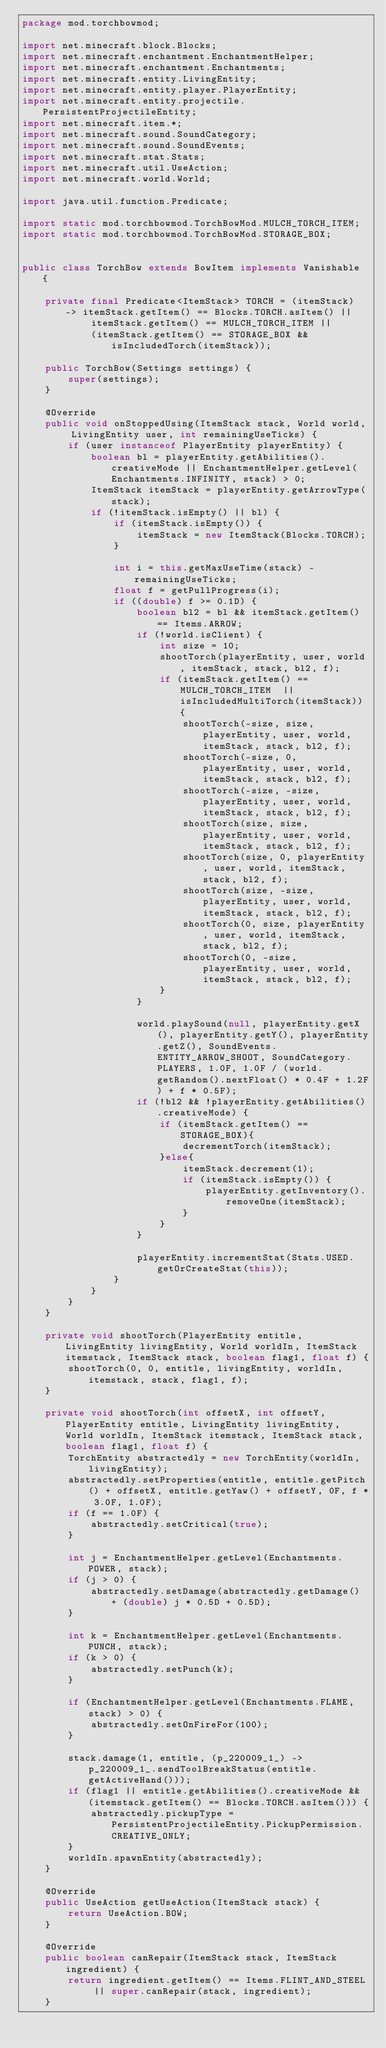<code> <loc_0><loc_0><loc_500><loc_500><_Java_>package mod.torchbowmod;

import net.minecraft.block.Blocks;
import net.minecraft.enchantment.EnchantmentHelper;
import net.minecraft.enchantment.Enchantments;
import net.minecraft.entity.LivingEntity;
import net.minecraft.entity.player.PlayerEntity;
import net.minecraft.entity.projectile.PersistentProjectileEntity;
import net.minecraft.item.*;
import net.minecraft.sound.SoundCategory;
import net.minecraft.sound.SoundEvents;
import net.minecraft.stat.Stats;
import net.minecraft.util.UseAction;
import net.minecraft.world.World;

import java.util.function.Predicate;

import static mod.torchbowmod.TorchBowMod.MULCH_TORCH_ITEM;
import static mod.torchbowmod.TorchBowMod.STORAGE_BOX;


public class TorchBow extends BowItem implements Vanishable {

    private final Predicate<ItemStack> TORCH = (itemStack) -> itemStack.getItem() == Blocks.TORCH.asItem() ||
            itemStack.getItem() == MULCH_TORCH_ITEM ||
            (itemStack.getItem() == STORAGE_BOX && isIncludedTorch(itemStack));

    public TorchBow(Settings settings) {
        super(settings);
    }

    @Override
    public void onStoppedUsing(ItemStack stack, World world, LivingEntity user, int remainingUseTicks) {
        if (user instanceof PlayerEntity playerEntity) {
            boolean bl = playerEntity.getAbilities().creativeMode || EnchantmentHelper.getLevel(Enchantments.INFINITY, stack) > 0;
            ItemStack itemStack = playerEntity.getArrowType(stack);
            if (!itemStack.isEmpty() || bl) {
                if (itemStack.isEmpty()) {
                    itemStack = new ItemStack(Blocks.TORCH);
                }

                int i = this.getMaxUseTime(stack) - remainingUseTicks;
                float f = getPullProgress(i);
                if ((double) f >= 0.1D) {
                    boolean bl2 = bl && itemStack.getItem() == Items.ARROW;
                    if (!world.isClient) {
                        int size = 10;
                        shootTorch(playerEntity, user, world, itemStack, stack, bl2, f);
                        if (itemStack.getItem() == MULCH_TORCH_ITEM  || isIncludedMultiTorch(itemStack)) {
                            shootTorch(-size, size, playerEntity, user, world, itemStack, stack, bl2, f);
                            shootTorch(-size, 0, playerEntity, user, world, itemStack, stack, bl2, f);
                            shootTorch(-size, -size, playerEntity, user, world, itemStack, stack, bl2, f);
                            shootTorch(size, size, playerEntity, user, world, itemStack, stack, bl2, f);
                            shootTorch(size, 0, playerEntity, user, world, itemStack, stack, bl2, f);
                            shootTorch(size, -size, playerEntity, user, world, itemStack, stack, bl2, f);
                            shootTorch(0, size, playerEntity, user, world, itemStack, stack, bl2, f);
                            shootTorch(0, -size, playerEntity, user, world, itemStack, stack, bl2, f);
                        }
                    }

                    world.playSound(null, playerEntity.getX(), playerEntity.getY(), playerEntity.getZ(), SoundEvents.ENTITY_ARROW_SHOOT, SoundCategory.PLAYERS, 1.0F, 1.0F / (world.getRandom().nextFloat() * 0.4F + 1.2F) + f * 0.5F);
                    if (!bl2 && !playerEntity.getAbilities().creativeMode) {
                        if (itemStack.getItem() == STORAGE_BOX){
                            decrementTorch(itemStack);
                        }else{
                            itemStack.decrement(1);
                            if (itemStack.isEmpty()) {
                                playerEntity.getInventory().removeOne(itemStack);
                            }
                        }
                    }

                    playerEntity.incrementStat(Stats.USED.getOrCreateStat(this));
                }
            }
        }
    }

    private void shootTorch(PlayerEntity entitle, LivingEntity livingEntity, World worldIn, ItemStack itemstack, ItemStack stack, boolean flag1, float f) {
        shootTorch(0, 0, entitle, livingEntity, worldIn, itemstack, stack, flag1, f);
    }

    private void shootTorch(int offsetX, int offsetY, PlayerEntity entitle, LivingEntity livingEntity, World worldIn, ItemStack itemstack, ItemStack stack, boolean flag1, float f) {
        TorchEntity abstractedly = new TorchEntity(worldIn, livingEntity);
        abstractedly.setProperties(entitle, entitle.getPitch() + offsetX, entitle.getYaw() + offsetY, 0F, f * 3.0F, 1.0F);
        if (f == 1.0F) {
            abstractedly.setCritical(true);
        }

        int j = EnchantmentHelper.getLevel(Enchantments.POWER, stack);
        if (j > 0) {
            abstractedly.setDamage(abstractedly.getDamage() + (double) j * 0.5D + 0.5D);
        }

        int k = EnchantmentHelper.getLevel(Enchantments.PUNCH, stack);
        if (k > 0) {
            abstractedly.setPunch(k);
        }

        if (EnchantmentHelper.getLevel(Enchantments.FLAME, stack) > 0) {
            abstractedly.setOnFireFor(100);
        }

        stack.damage(1, entitle, (p_220009_1_) -> p_220009_1_.sendToolBreakStatus(entitle.getActiveHand()));
        if (flag1 || entitle.getAbilities().creativeMode && (itemstack.getItem() == Blocks.TORCH.asItem())) {
            abstractedly.pickupType = PersistentProjectileEntity.PickupPermission.CREATIVE_ONLY;
        }
        worldIn.spawnEntity(abstractedly);
    }

    @Override
    public UseAction getUseAction(ItemStack stack) {
        return UseAction.BOW;
    }

    @Override
    public boolean canRepair(ItemStack stack, ItemStack ingredient) {
        return ingredient.getItem() == Items.FLINT_AND_STEEL || super.canRepair(stack, ingredient);
    }
</code> 